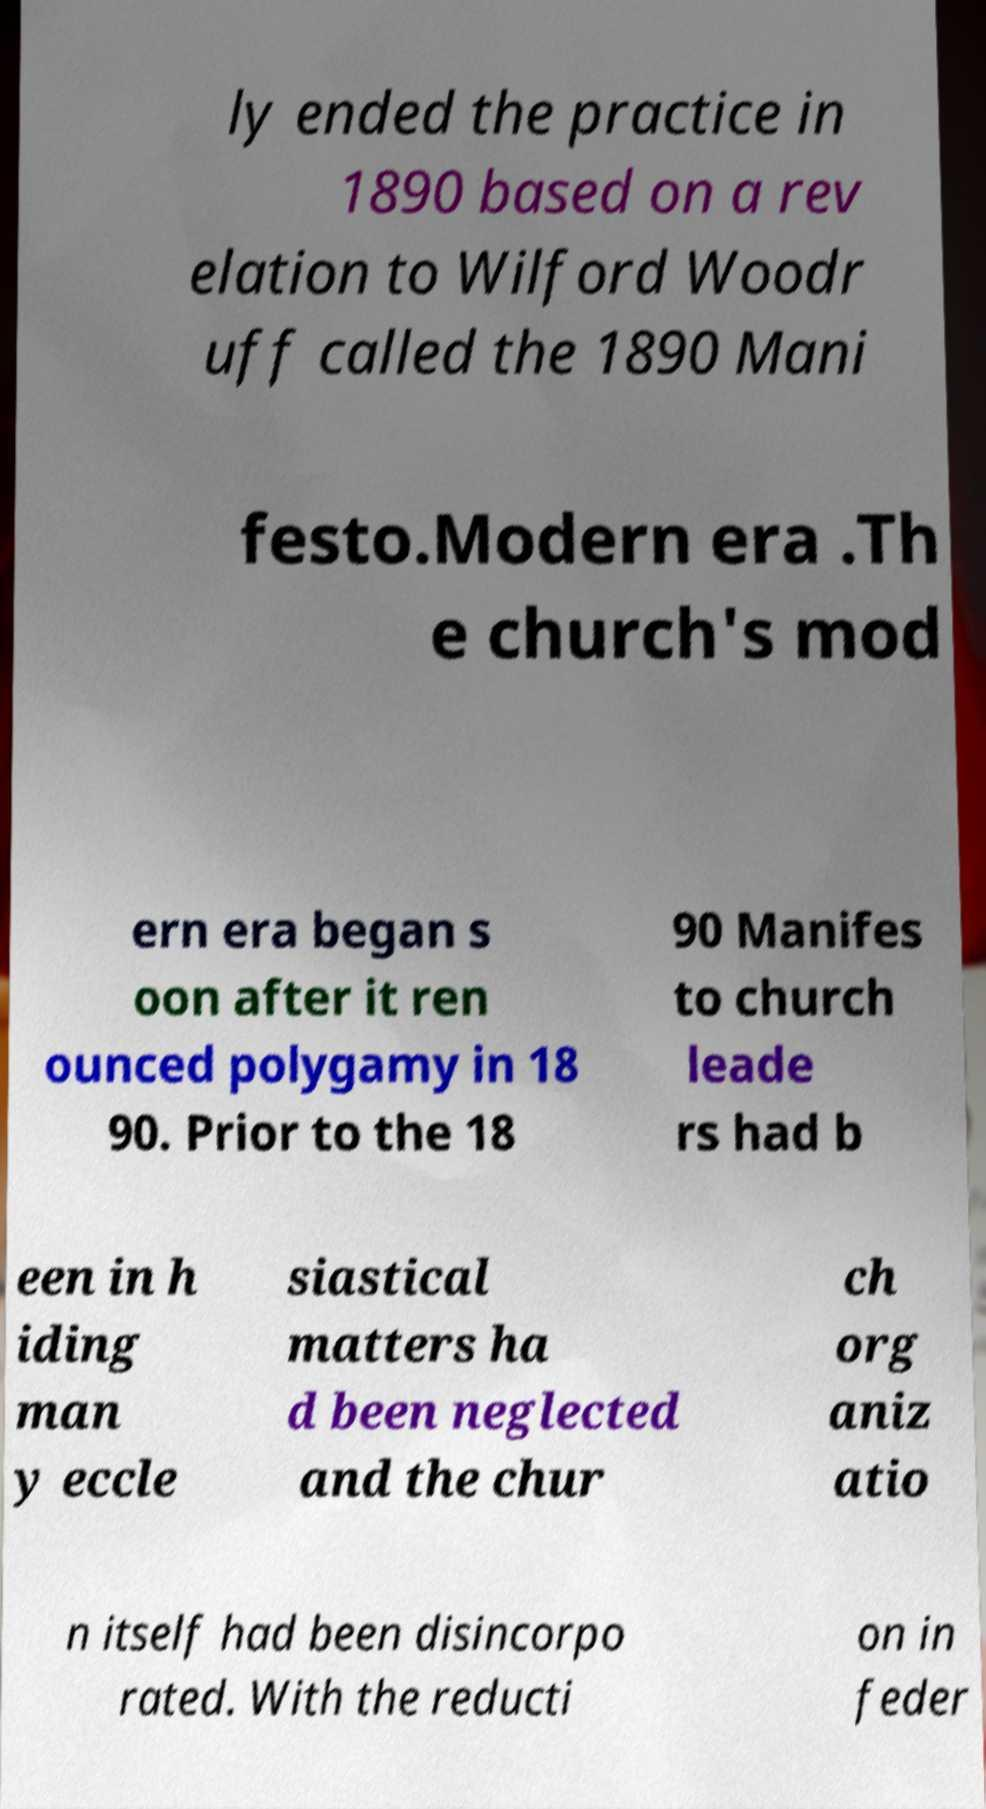There's text embedded in this image that I need extracted. Can you transcribe it verbatim? ly ended the practice in 1890 based on a rev elation to Wilford Woodr uff called the 1890 Mani festo.Modern era .Th e church's mod ern era began s oon after it ren ounced polygamy in 18 90. Prior to the 18 90 Manifes to church leade rs had b een in h iding man y eccle siastical matters ha d been neglected and the chur ch org aniz atio n itself had been disincorpo rated. With the reducti on in feder 